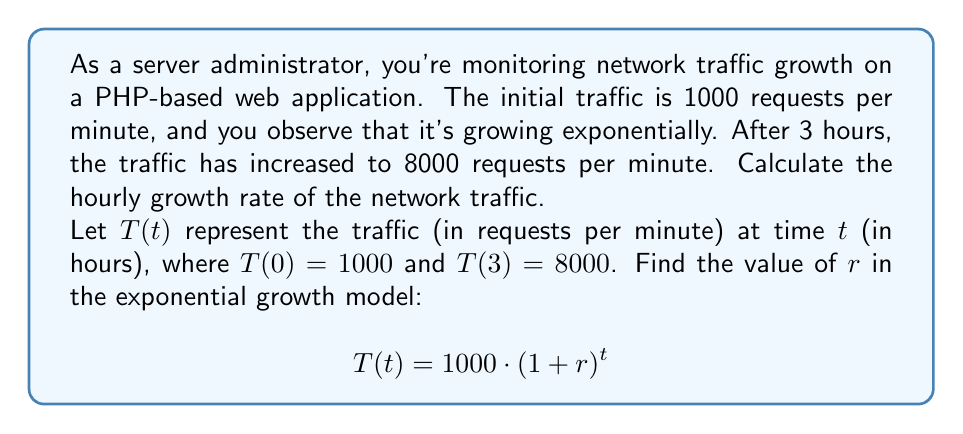Can you solve this math problem? To solve this problem, we'll use the exponential growth formula and the given information:

1) The general form of exponential growth is:
   $$T(t) = T_0 \cdot (1 + r)^t$$
   where $T_0$ is the initial value, $r$ is the growth rate, and $t$ is the time.

2) We know:
   $T_0 = 1000$ (initial traffic)
   $T(3) = 8000$ (traffic after 3 hours)
   $t = 3$ (time elapsed in hours)

3) Substituting these values into the formula:
   $$8000 = 1000 \cdot (1 + r)^3$$

4) Divide both sides by 1000:
   $$8 = (1 + r)^3$$

5) Take the cube root of both sides:
   $$\sqrt[3]{8} = 1 + r$$

6) Simplify:
   $$2 = 1 + r$$

7) Solve for $r$:
   $$r = 2 - 1 = 1$$

8) Convert to a percentage:
   $$r = 1 = 100\%$$

Therefore, the hourly growth rate is 100%.
Answer: The hourly growth rate of the network traffic is 100%. 